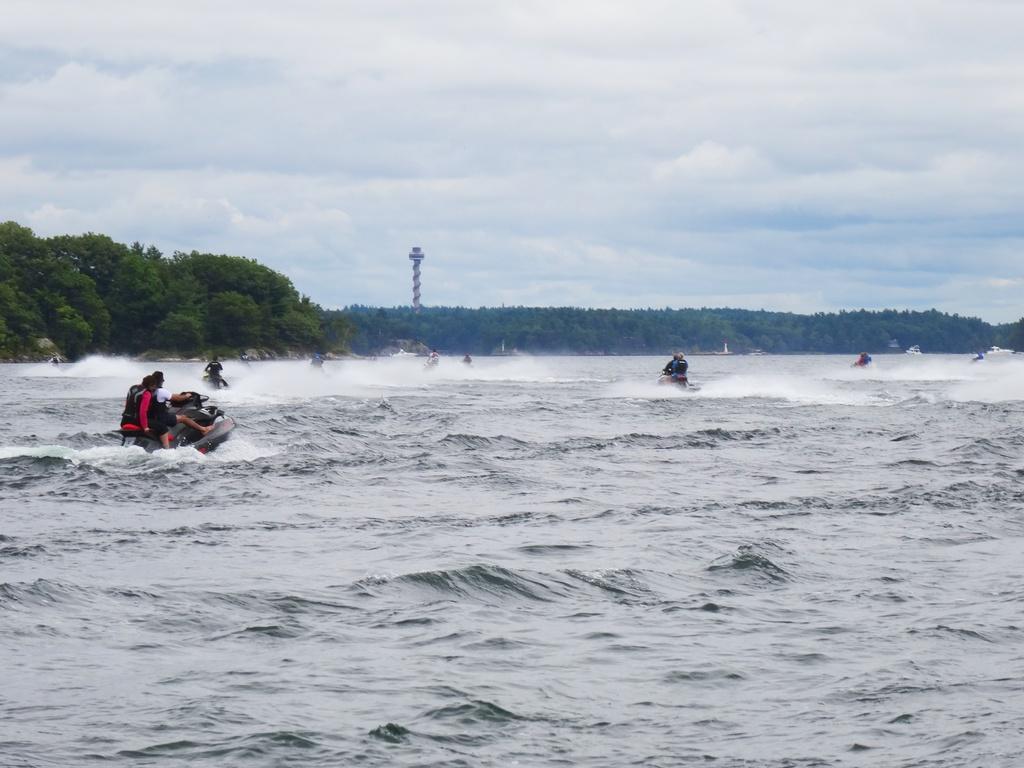Describe this image in one or two sentences. In this image there is a beach and in the beach there are there are some people who are sitting on boats and riding, and in the background there are trees and tower. At the top there is sky. 